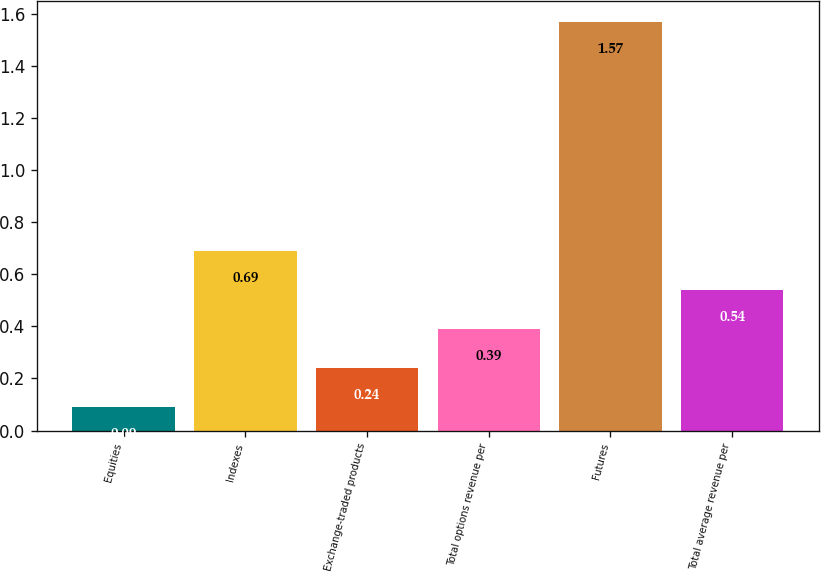<chart> <loc_0><loc_0><loc_500><loc_500><bar_chart><fcel>Equities<fcel>Indexes<fcel>Exchange-traded products<fcel>Total options revenue per<fcel>Futures<fcel>Total average revenue per<nl><fcel>0.09<fcel>0.69<fcel>0.24<fcel>0.39<fcel>1.57<fcel>0.54<nl></chart> 